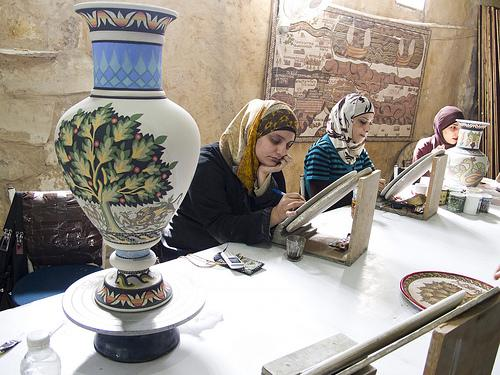Identify a unique feature on the vase being painted, and describe it. There's a drawing of a tree on the vase, which is possibly being painted or is already part of the intricate design. What are the three main objects on the table? The three main objects on the table are a large decorative pottery, a painted plate with a red rim, and a dark liquid in a glass. Count and enumerate the total number of plates that can be identified in the image. There are three identifiable plates: a decorative plate on the table, a painted plate with a red rim, and a decorative plate sitting on the table. What unique items are found in the room where the three women are sitting? Some unique items include a large painted vase on a wheel, a hanging woven tapestry, and two decorative plates on wooden easels. Assuming they're working together, describe the artistic process of the women in the image. The women are likely creating and decorating pottery, with one of them actively painting designs on a vase while the others might be offering guidance or working on other aspects of the process. Provide a brief summary of the setting and main subjects in the image. The photo captures three women wearing head coverings, sitting around a long table adorned with decorative plates and vases. One is holding a writing utensil, painting on a vase with her pinkie resting for stability. Identify the number of women in the image, their attire, and where they are sitting. There are three women, all wearing head coverings, sitting on the same side of a long table. Describe the setting and any notable elements on the walls of the room where the women are. The setting is an indoor space with a brown wall behind a woman, and decorations on the wall including a hanging woven tapestry and assorted cups near the vase one woman is working on. Describe the actions and appearance of the person painting on the vase. A woman wearing a head covering is holding a brush and using her pinkie for stability while focusing on painting intricate designs on a vase. Analyze the image and describe the possible sentiment or atmosphere being conveyed. The image portrays a calm and tranquil atmosphere, as the women are engaged in delicate artwork and are surrounded by beautiful decorative items. 